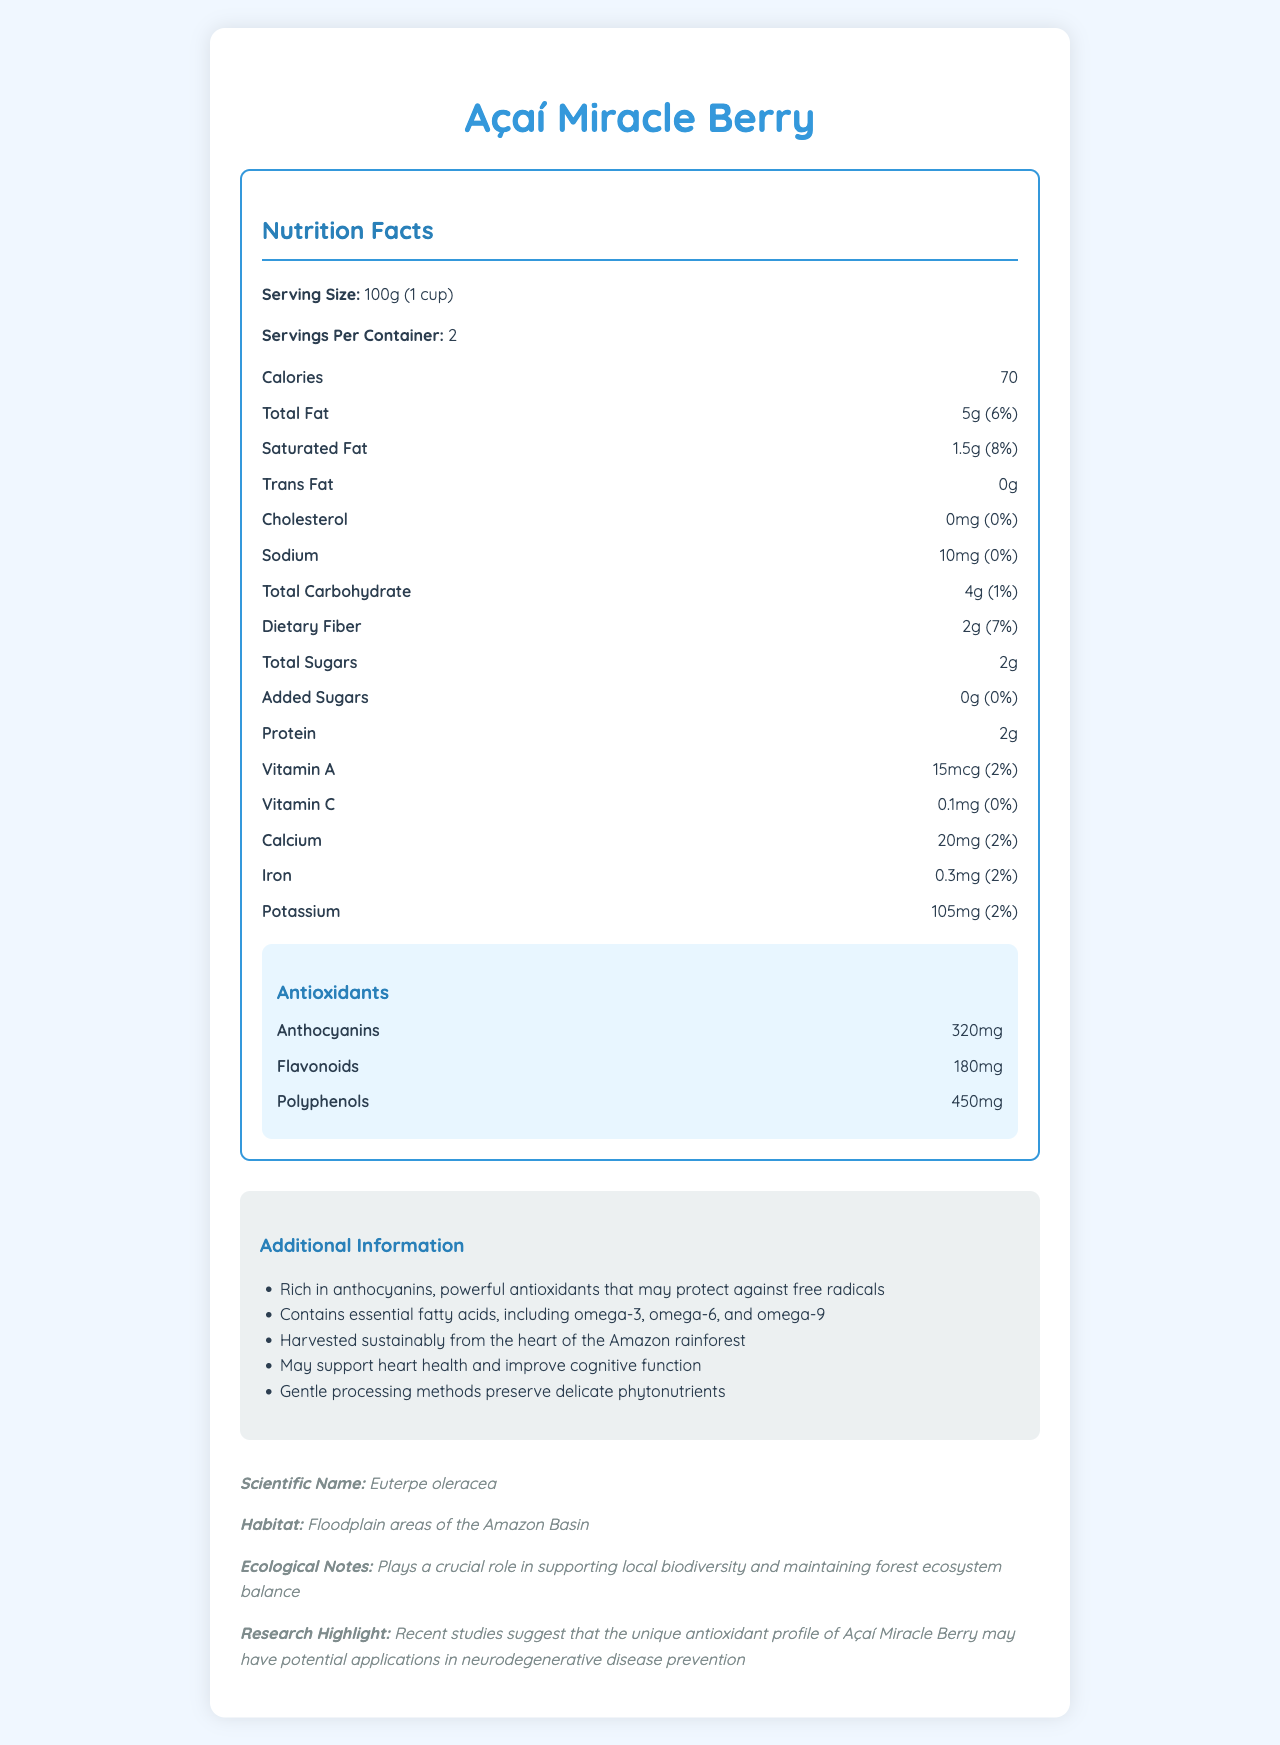What is the serving size of Açaí Miracle Berry? The serving size is listed at the top of the nutrition label under "Serving Size."
Answer: 100g (1 cup) How much Total Fat is in one serving? The amount of Total Fat per serving is specified as 5g.
Answer: 5g What percentage of the daily value does Saturated Fat represent? The percentage of daily value for Saturated Fat is given as 8%.
Answer: 8% How many calories are in one serving? The number of calories per serving is listed as 70.
Answer: 70 Does the Açaí Miracle Berry contain any cholesterol? The label states 0mg cholesterol with a 0% daily value, indicating there is no cholesterol.
Answer: No How much protein is present in one serving? The amount of protein per serving is listed as 2g.
Answer: 2g What is the sodium content per serving? A. 10mg B. 5mg C. 20mg D. 0mg The sodium content per serving is given as 10mg.
Answer: A. 10mg What type of antioxidants does the Açaí Miracle Berry contain? A. Anthocyanins B. Flavonoids C. Polyphenols D. All of the above The antioxidants section lists Anthocyanins, Flavonoids, and Polyphenols.
Answer: D. All of the above Is the Açaí Miracle Berry high in added sugars? It contains 0g of added sugars, indicating it is not high in added sugars.
Answer: No Summarize the main nutritional benefits and additional information provided about the Açaí Miracle Berry. The document provides a detailed nutritional profile of the Açaí Miracle Berry, highlighting its low calorie and cholesterol content, richness in antioxidants, and essential fatty acids. It also includes information on its sustainable harvesting and potential health benefits.
Answer: The Açaí Miracle Berry is low in calories, has no cholesterol, and is rich in essential fatty acids and antioxidants like anthocyanins, flavonoids, and polyphenols. It contains moderate amounts of protein, fiber, and essential minerals with minimal sodium and sugars. It is sustainably harvested and may support heart health and cognitive function. What is the scientific name of the Açaí Miracle Berry? The scientific name is listed under the scientific info section as Euterpe oleracea.
Answer: Euterpe oleracea Can the Açaí Miracle Berry play a role in neurodegenerative disease prevention based on recent studies? The research highlight indicates that recent studies suggest the berry's unique antioxidant profile may have potential applications in neurodegenerative disease prevention.
Answer: Yes Where is the Açaí Miracle Berry primarily found? The habitat section specifies that the berry is found in the floodplain areas of the Amazon Basin.
Answer: Floodplain areas of the Amazon Basin What are the dietary fiber benefits of Açaí Miracle Berry? The nutrition label indicates that each serving contains 2g of dietary fiber, which is 7% of the daily value.
Answer: 2g dietary fiber, 7% daily value What is the calcium content per serving? The calcium content per serving is listed as 20mg.
Answer: 20mg How much vitamin C does one serving of Açaí Miracle Berry provide? The Vitamin C amount per serving is specified as 0.1mg.
Answer: 0.1mg Can the total amount of carbohydrates be determined solely based on the visual information in the document? The total amount of carbohydrates is listed as 4g per serving.
Answer: Yes Does the Açaí Miracle Berry contain any transfat? The label clearly shows 0g of Trans Fat.
Answer: No 